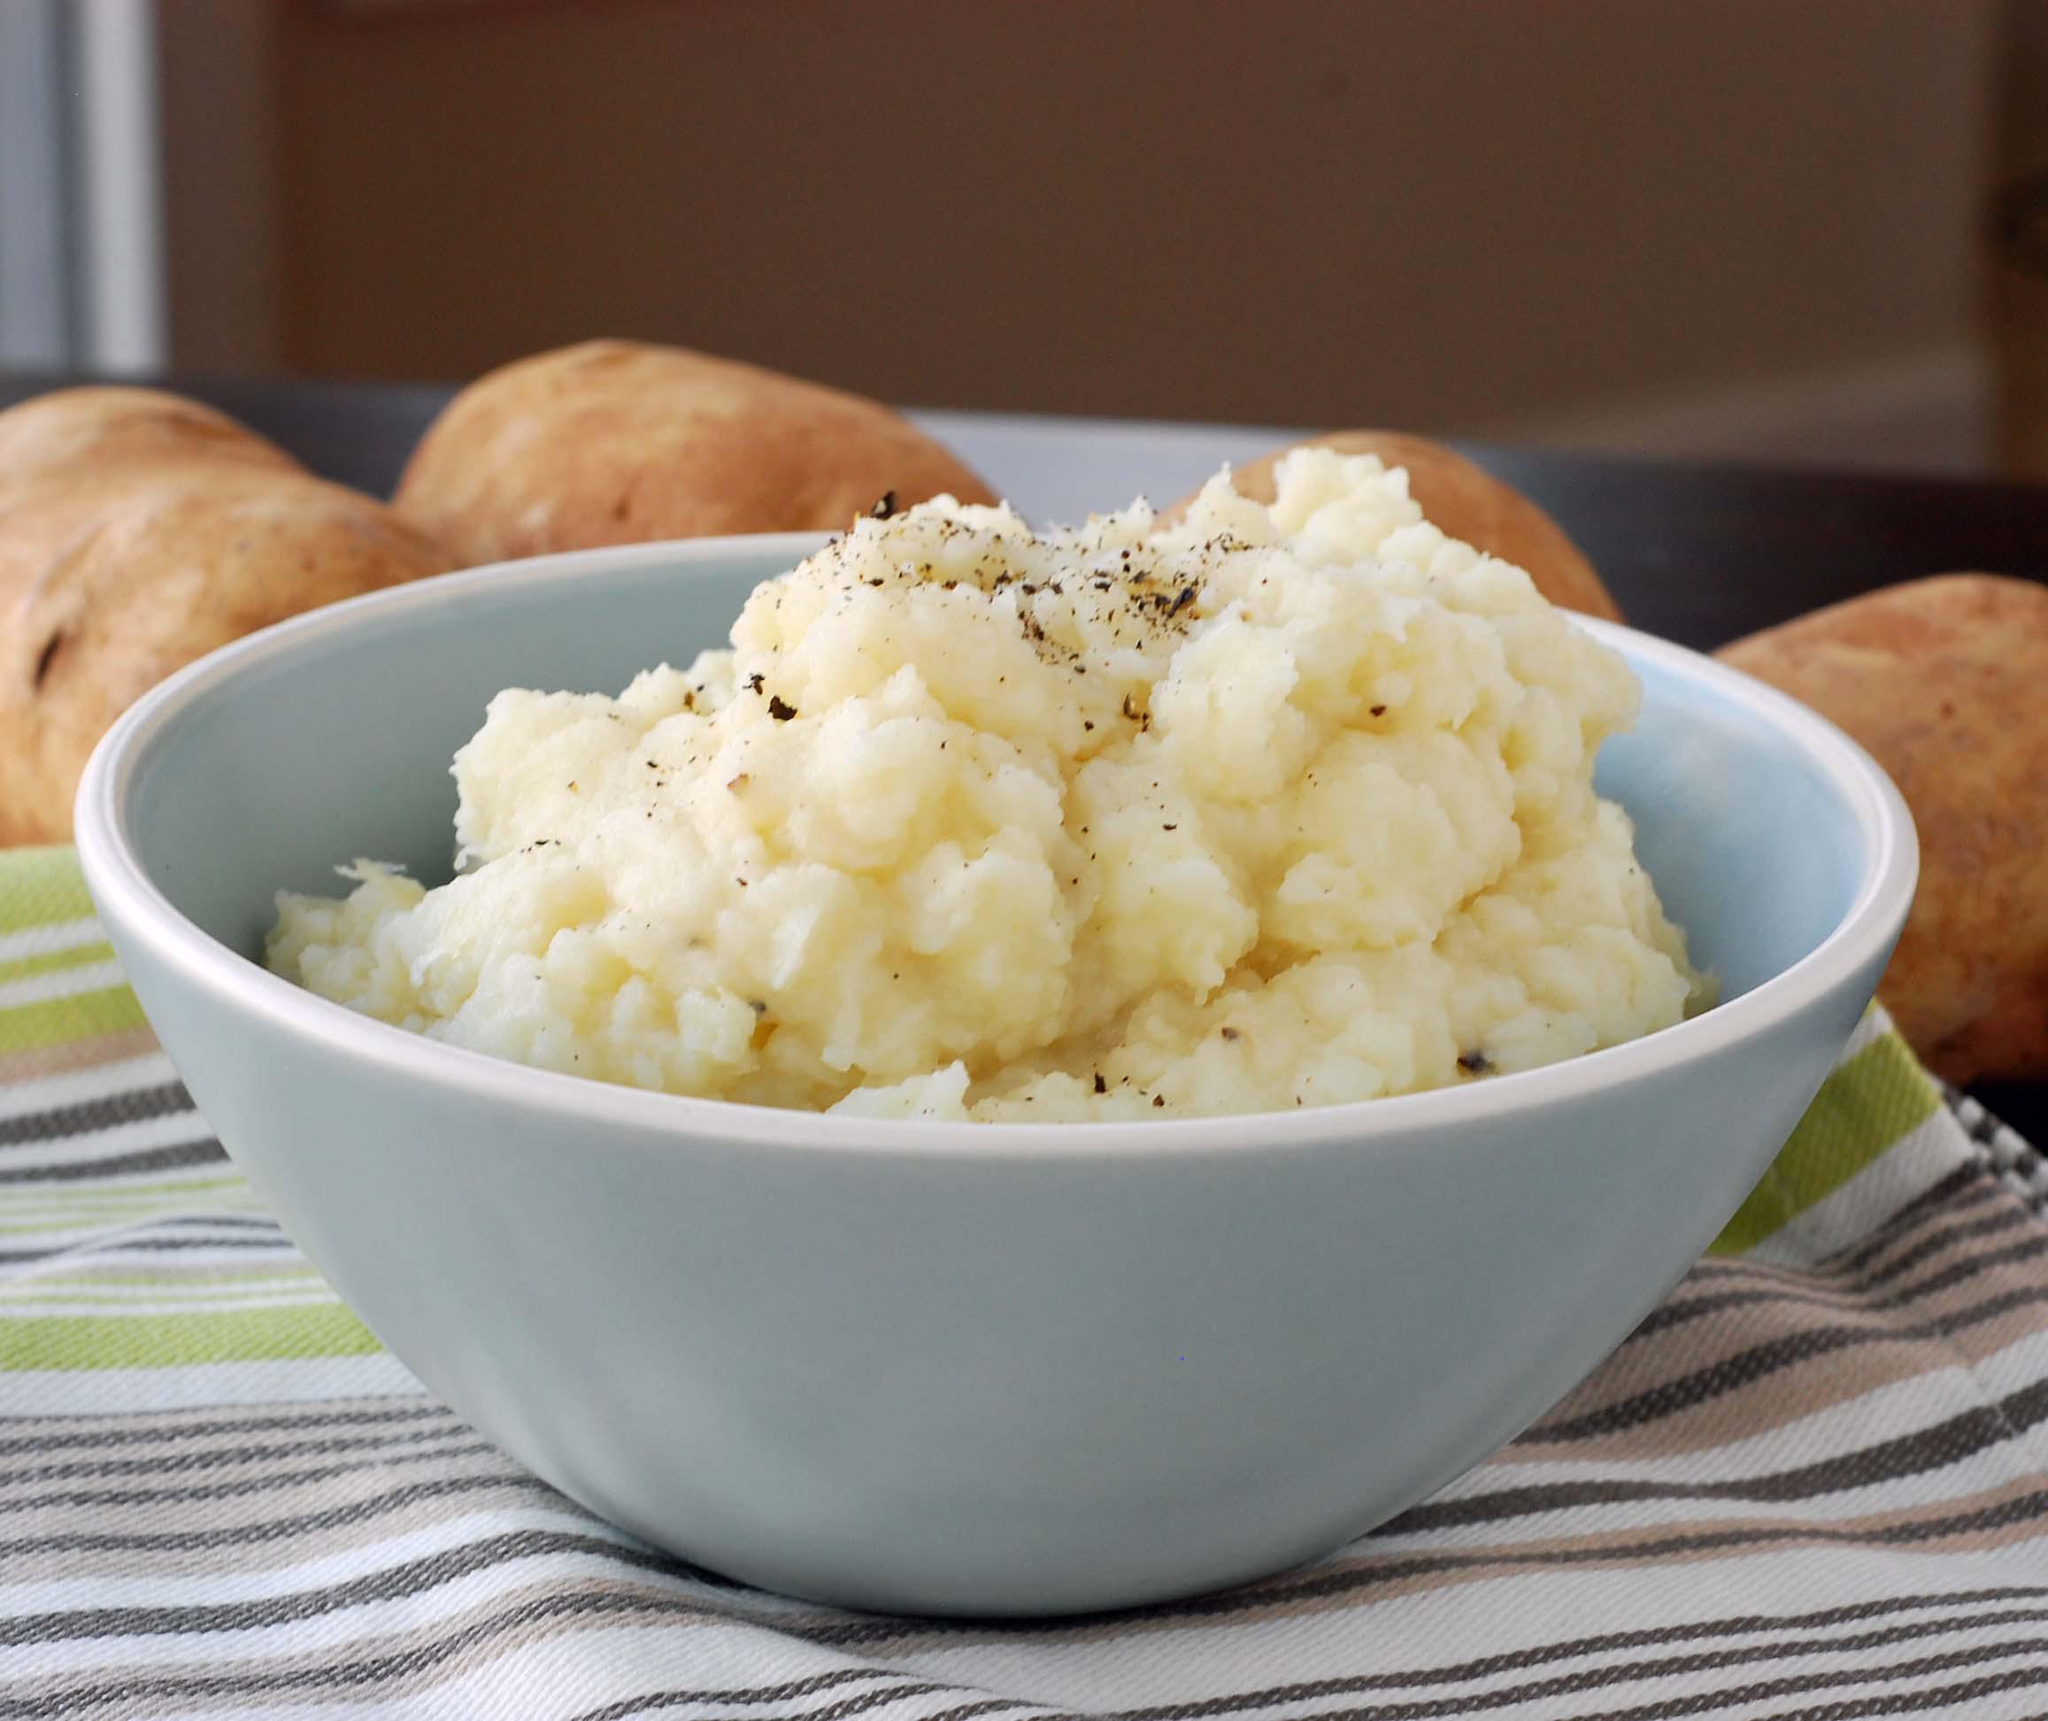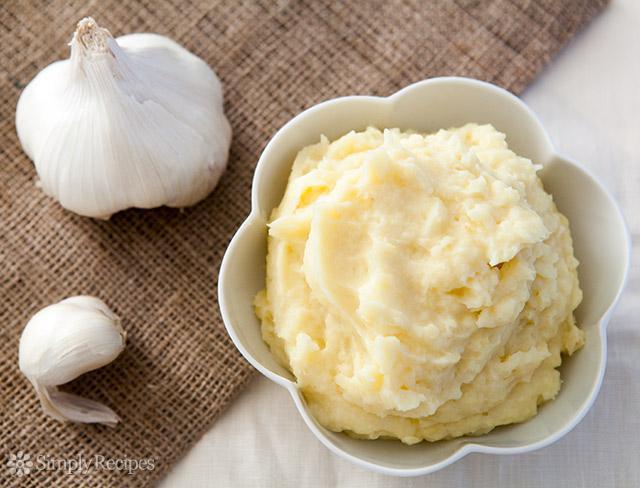The first image is the image on the left, the second image is the image on the right. Considering the images on both sides, is "A white bowl of mashed potato is on top of a round placemat." valid? Answer yes or no. No. The first image is the image on the left, the second image is the image on the right. Given the left and right images, does the statement "An image shows a piece of silverware on a surface to the right of a bowl of potatoes." hold true? Answer yes or no. No. 